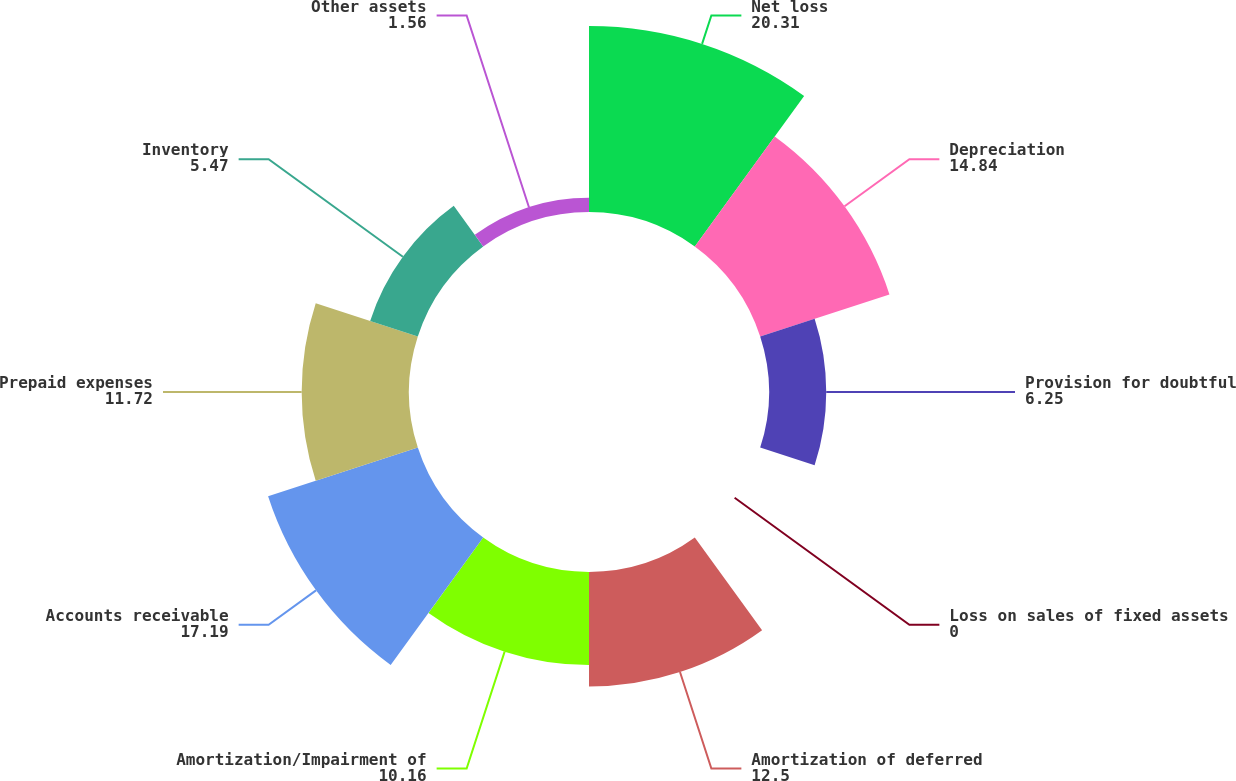Convert chart. <chart><loc_0><loc_0><loc_500><loc_500><pie_chart><fcel>Net loss<fcel>Depreciation<fcel>Provision for doubtful<fcel>Loss on sales of fixed assets<fcel>Amortization of deferred<fcel>Amortization/Impairment of<fcel>Accounts receivable<fcel>Prepaid expenses<fcel>Inventory<fcel>Other assets<nl><fcel>20.31%<fcel>14.84%<fcel>6.25%<fcel>0.0%<fcel>12.5%<fcel>10.16%<fcel>17.19%<fcel>11.72%<fcel>5.47%<fcel>1.56%<nl></chart> 